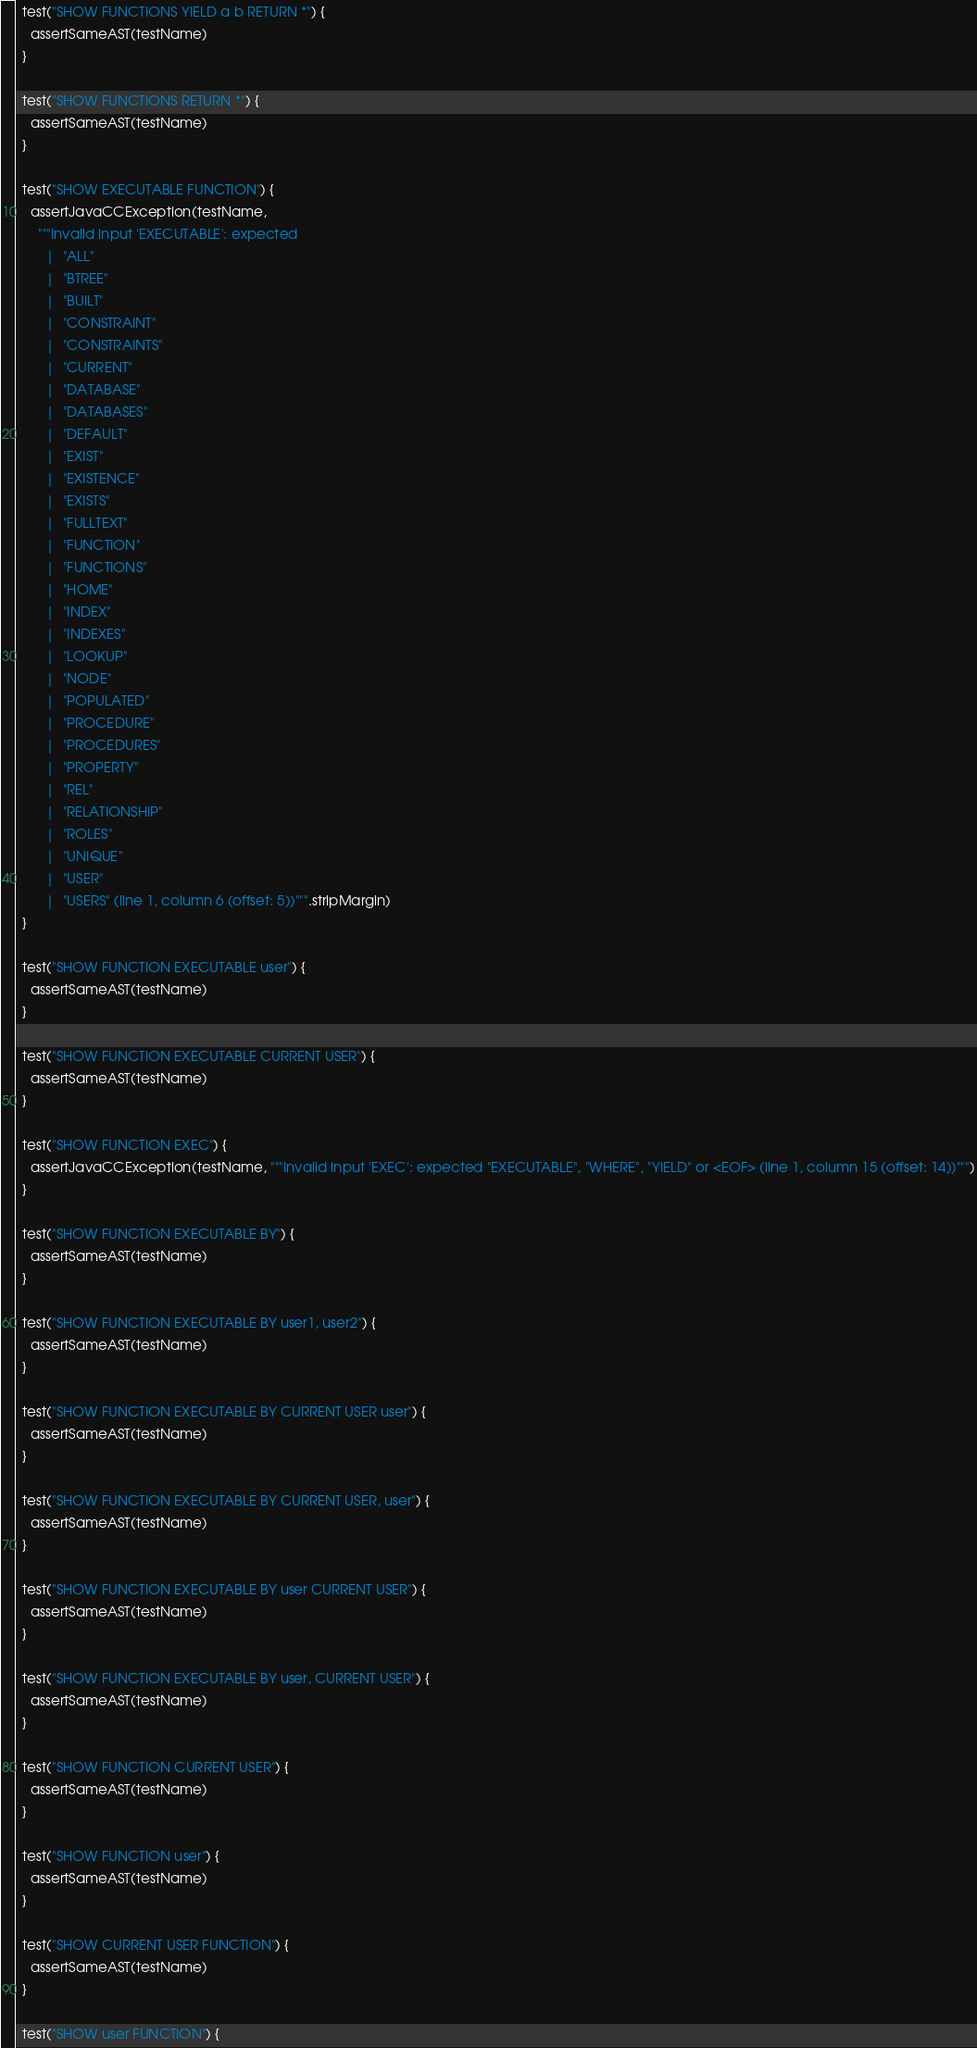<code> <loc_0><loc_0><loc_500><loc_500><_Scala_>
  test("SHOW FUNCTIONS YIELD a b RETURN *") {
    assertSameAST(testName)
  }

  test("SHOW FUNCTIONS RETURN *") {
    assertSameAST(testName)
  }

  test("SHOW EXECUTABLE FUNCTION") {
    assertJavaCCException(testName,
      """Invalid input 'EXECUTABLE': expected
        |  "ALL"
        |  "BTREE"
        |  "BUILT"
        |  "CONSTRAINT"
        |  "CONSTRAINTS"
        |  "CURRENT"
        |  "DATABASE"
        |  "DATABASES"
        |  "DEFAULT"
        |  "EXIST"
        |  "EXISTENCE"
        |  "EXISTS"
        |  "FULLTEXT"
        |  "FUNCTION"
        |  "FUNCTIONS"
        |  "HOME"
        |  "INDEX"
        |  "INDEXES"
        |  "LOOKUP"
        |  "NODE"
        |  "POPULATED"
        |  "PROCEDURE"
        |  "PROCEDURES"
        |  "PROPERTY"
        |  "REL"
        |  "RELATIONSHIP"
        |  "ROLES"
        |  "UNIQUE"
        |  "USER"
        |  "USERS" (line 1, column 6 (offset: 5))""".stripMargin)
  }

  test("SHOW FUNCTION EXECUTABLE user") {
    assertSameAST(testName)
  }

  test("SHOW FUNCTION EXECUTABLE CURRENT USER") {
    assertSameAST(testName)
  }

  test("SHOW FUNCTION EXEC") {
    assertJavaCCException(testName, """Invalid input 'EXEC': expected "EXECUTABLE", "WHERE", "YIELD" or <EOF> (line 1, column 15 (offset: 14))""")
  }

  test("SHOW FUNCTION EXECUTABLE BY") {
    assertSameAST(testName)
  }

  test("SHOW FUNCTION EXECUTABLE BY user1, user2") {
    assertSameAST(testName)
  }

  test("SHOW FUNCTION EXECUTABLE BY CURRENT USER user") {
    assertSameAST(testName)
  }

  test("SHOW FUNCTION EXECUTABLE BY CURRENT USER, user") {
    assertSameAST(testName)
  }

  test("SHOW FUNCTION EXECUTABLE BY user CURRENT USER") {
    assertSameAST(testName)
  }

  test("SHOW FUNCTION EXECUTABLE BY user, CURRENT USER") {
    assertSameAST(testName)
  }

  test("SHOW FUNCTION CURRENT USER") {
    assertSameAST(testName)
  }

  test("SHOW FUNCTION user") {
    assertSameAST(testName)
  }

  test("SHOW CURRENT USER FUNCTION") {
    assertSameAST(testName)
  }

  test("SHOW user FUNCTION") {</code> 